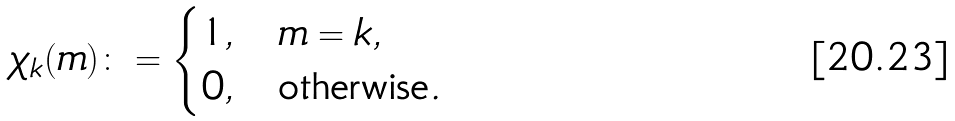<formula> <loc_0><loc_0><loc_500><loc_500>\chi _ { k } ( m ) \colon = \begin{cases} 1 , & m = k , \\ 0 , & \text {otherwise} . \end{cases}</formula> 